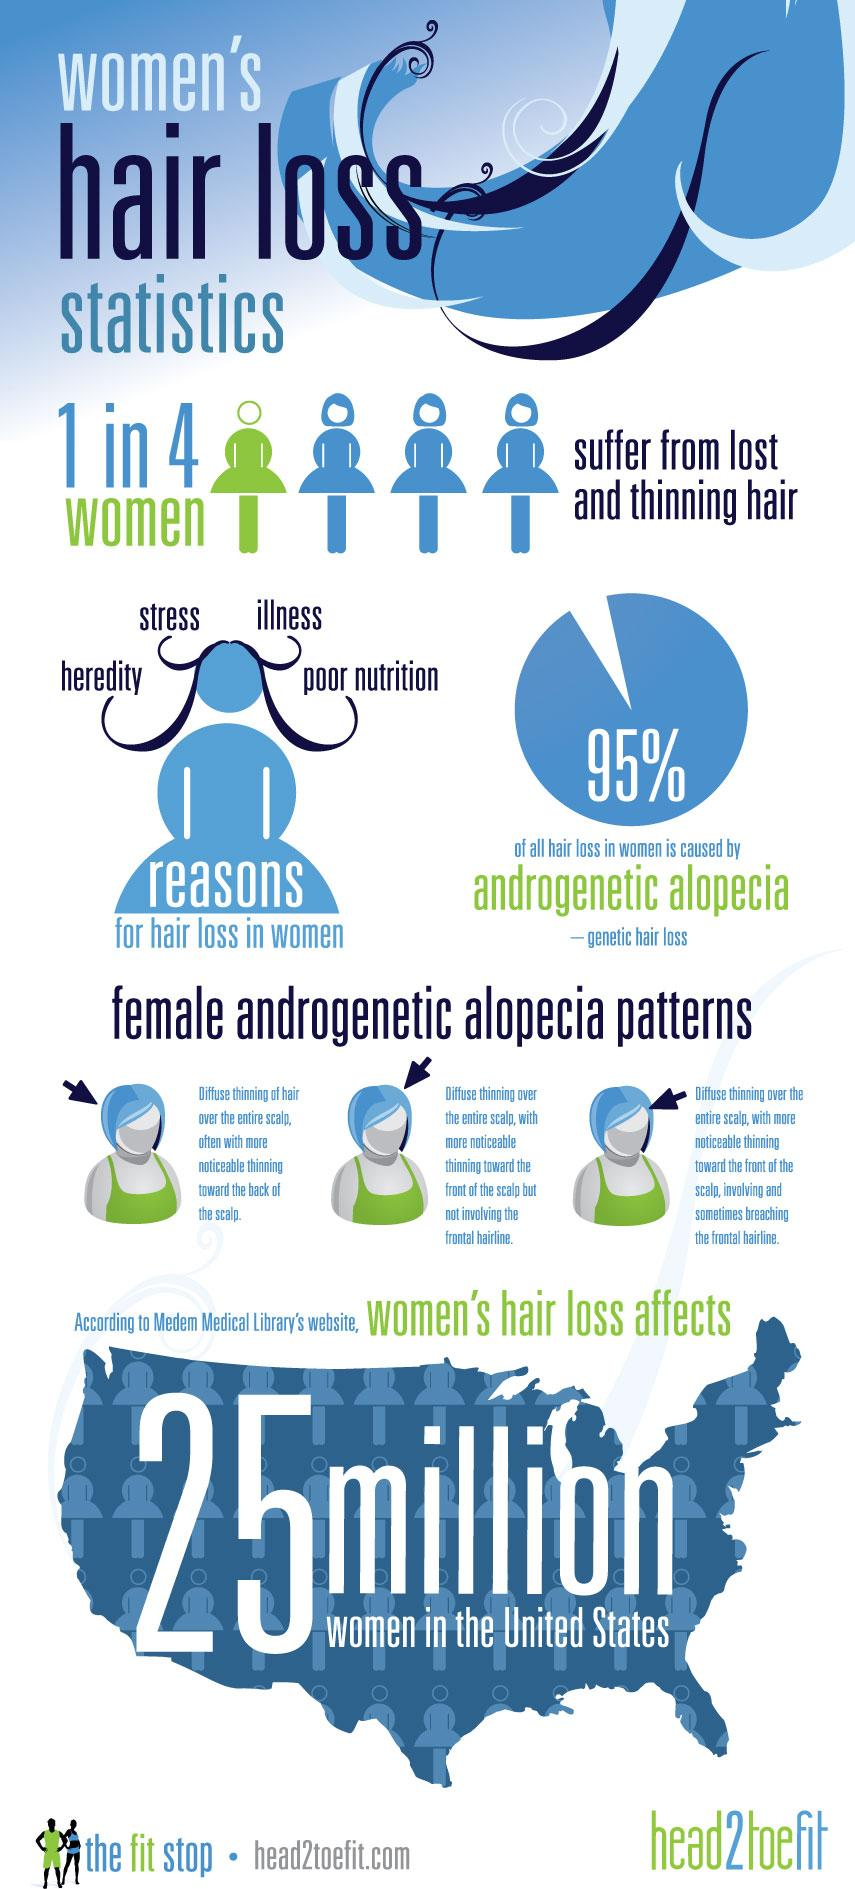Mention a couple of crucial points in this snapshot. According to studies, only 5% of women experience hair loss due to reasons other than androgenetic alopecia. 